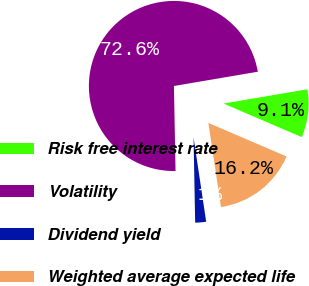Convert chart to OTSL. <chart><loc_0><loc_0><loc_500><loc_500><pie_chart><fcel>Risk free interest rate<fcel>Volatility<fcel>Dividend yield<fcel>Weighted average expected life<nl><fcel>9.13%<fcel>72.61%<fcel>2.07%<fcel>16.18%<nl></chart> 